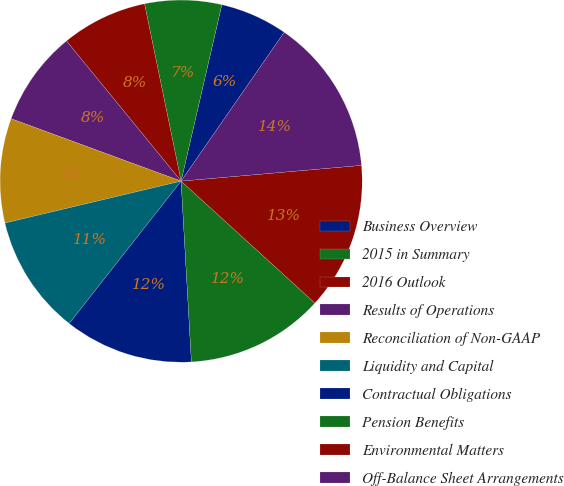<chart> <loc_0><loc_0><loc_500><loc_500><pie_chart><fcel>Business Overview<fcel>2015 in Summary<fcel>2016 Outlook<fcel>Results of Operations<fcel>Reconciliation of Non-GAAP<fcel>Liquidity and Capital<fcel>Contractual Obligations<fcel>Pension Benefits<fcel>Environmental Matters<fcel>Off-Balance Sheet Arrangements<nl><fcel>6.03%<fcel>6.85%<fcel>7.67%<fcel>8.49%<fcel>9.32%<fcel>10.68%<fcel>11.51%<fcel>12.33%<fcel>13.15%<fcel>13.97%<nl></chart> 